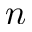<formula> <loc_0><loc_0><loc_500><loc_500>n</formula> 